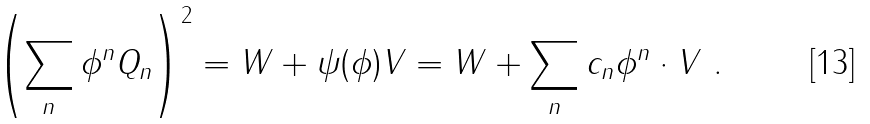Convert formula to latex. <formula><loc_0><loc_0><loc_500><loc_500>\left ( \sum _ { n } \phi ^ { n } Q _ { n } \right ) ^ { 2 } = W + \psi ( \phi ) V = W + \sum _ { n } c _ { n } \phi ^ { n } \cdot V \ .</formula> 